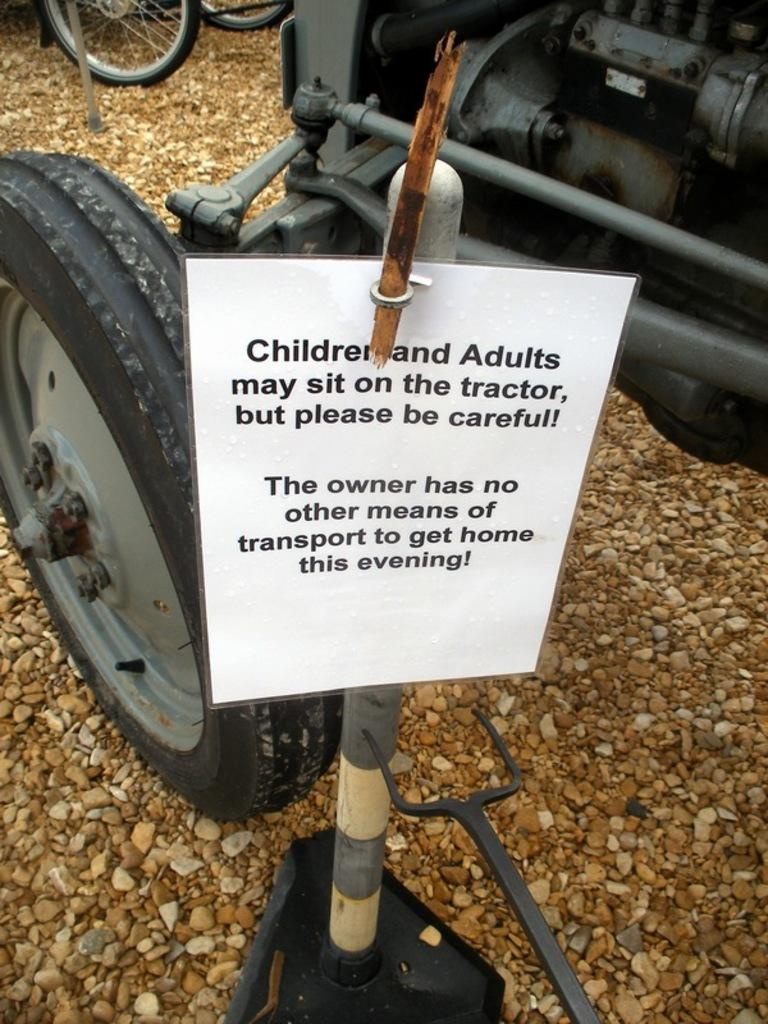What type of object is shown from the side in the image? There is a vehicle in the image, and it is shown from the side. What part of the vehicle can be seen in the top left of the image? There are wheels visible in the top left of the image. What is located in the middle of the image? There is a board in the middle of the image. What type of window can be seen in the image? There is no window present in the image; it features a vehicle and a board. 